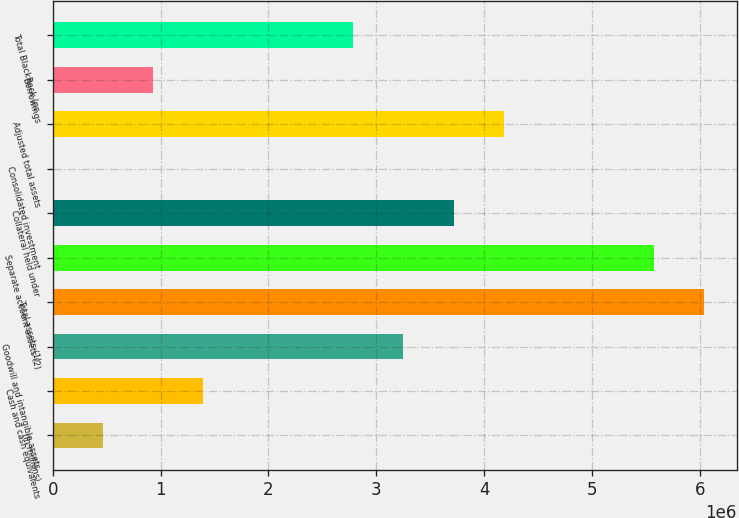Convert chart to OTSL. <chart><loc_0><loc_0><loc_500><loc_500><bar_chart><fcel>(in millions)<fcel>Cash and cash equivalents<fcel>Goodwill and intangible assets<fcel>Total assets (1)<fcel>Separate account assets (2)<fcel>Collateral held under<fcel>Consolidated investment<fcel>Adjusted total assets<fcel>Borrowings<fcel>Total BlackRock Inc<nl><fcel>465151<fcel>1.3941e+06<fcel>3.25199e+06<fcel>6.03883e+06<fcel>5.57436e+06<fcel>3.71647e+06<fcel>678<fcel>4.18094e+06<fcel>929625<fcel>2.78752e+06<nl></chart> 